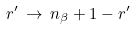Convert formula to latex. <formula><loc_0><loc_0><loc_500><loc_500>r ^ { \prime } \, \rightarrow \, n _ { \beta } + 1 - r ^ { \prime }</formula> 